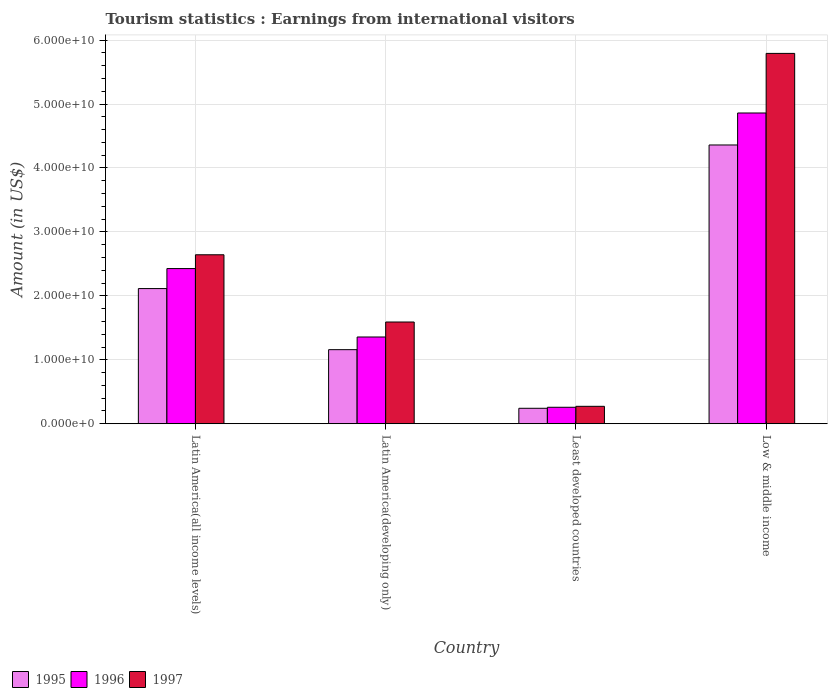How many groups of bars are there?
Your answer should be compact. 4. Are the number of bars per tick equal to the number of legend labels?
Give a very brief answer. Yes. Are the number of bars on each tick of the X-axis equal?
Your answer should be compact. Yes. How many bars are there on the 3rd tick from the left?
Offer a terse response. 3. What is the label of the 1st group of bars from the left?
Make the answer very short. Latin America(all income levels). What is the earnings from international visitors in 1997 in Latin America(developing only)?
Ensure brevity in your answer.  1.59e+1. Across all countries, what is the maximum earnings from international visitors in 1995?
Your response must be concise. 4.36e+1. Across all countries, what is the minimum earnings from international visitors in 1995?
Offer a very short reply. 2.42e+09. In which country was the earnings from international visitors in 1997 maximum?
Make the answer very short. Low & middle income. In which country was the earnings from international visitors in 1996 minimum?
Provide a succinct answer. Least developed countries. What is the total earnings from international visitors in 1997 in the graph?
Make the answer very short. 1.03e+11. What is the difference between the earnings from international visitors in 1995 in Latin America(all income levels) and that in Low & middle income?
Ensure brevity in your answer.  -2.25e+1. What is the difference between the earnings from international visitors in 1995 in Latin America(developing only) and the earnings from international visitors in 1997 in Least developed countries?
Your answer should be compact. 8.86e+09. What is the average earnings from international visitors in 1996 per country?
Keep it short and to the point. 2.23e+1. What is the difference between the earnings from international visitors of/in 1997 and earnings from international visitors of/in 1995 in Low & middle income?
Offer a very short reply. 1.43e+1. In how many countries, is the earnings from international visitors in 1997 greater than 10000000000 US$?
Your response must be concise. 3. What is the ratio of the earnings from international visitors in 1996 in Latin America(all income levels) to that in Latin America(developing only)?
Your answer should be very brief. 1.79. Is the earnings from international visitors in 1997 in Latin America(all income levels) less than that in Least developed countries?
Your response must be concise. No. Is the difference between the earnings from international visitors in 1997 in Latin America(developing only) and Least developed countries greater than the difference between the earnings from international visitors in 1995 in Latin America(developing only) and Least developed countries?
Ensure brevity in your answer.  Yes. What is the difference between the highest and the second highest earnings from international visitors in 1997?
Offer a terse response. -4.20e+1. What is the difference between the highest and the lowest earnings from international visitors in 1995?
Keep it short and to the point. 4.12e+1. In how many countries, is the earnings from international visitors in 1996 greater than the average earnings from international visitors in 1996 taken over all countries?
Keep it short and to the point. 2. Is the sum of the earnings from international visitors in 1997 in Latin America(developing only) and Least developed countries greater than the maximum earnings from international visitors in 1996 across all countries?
Give a very brief answer. No. What does the 1st bar from the right in Latin America(all income levels) represents?
Your answer should be very brief. 1997. How many bars are there?
Your answer should be compact. 12. Are all the bars in the graph horizontal?
Provide a short and direct response. No. Does the graph contain any zero values?
Provide a succinct answer. No. Does the graph contain grids?
Keep it short and to the point. Yes. How many legend labels are there?
Your response must be concise. 3. How are the legend labels stacked?
Your answer should be very brief. Horizontal. What is the title of the graph?
Provide a succinct answer. Tourism statistics : Earnings from international visitors. Does "1973" appear as one of the legend labels in the graph?
Your answer should be compact. No. What is the Amount (in US$) of 1995 in Latin America(all income levels)?
Make the answer very short. 2.11e+1. What is the Amount (in US$) in 1996 in Latin America(all income levels)?
Your answer should be compact. 2.43e+1. What is the Amount (in US$) of 1997 in Latin America(all income levels)?
Offer a terse response. 2.64e+1. What is the Amount (in US$) in 1995 in Latin America(developing only)?
Give a very brief answer. 1.16e+1. What is the Amount (in US$) in 1996 in Latin America(developing only)?
Provide a short and direct response. 1.36e+1. What is the Amount (in US$) of 1997 in Latin America(developing only)?
Provide a succinct answer. 1.59e+1. What is the Amount (in US$) of 1995 in Least developed countries?
Ensure brevity in your answer.  2.42e+09. What is the Amount (in US$) of 1996 in Least developed countries?
Provide a succinct answer. 2.57e+09. What is the Amount (in US$) in 1997 in Least developed countries?
Your answer should be compact. 2.72e+09. What is the Amount (in US$) in 1995 in Low & middle income?
Your answer should be very brief. 4.36e+1. What is the Amount (in US$) of 1996 in Low & middle income?
Your answer should be compact. 4.86e+1. What is the Amount (in US$) of 1997 in Low & middle income?
Make the answer very short. 5.79e+1. Across all countries, what is the maximum Amount (in US$) of 1995?
Give a very brief answer. 4.36e+1. Across all countries, what is the maximum Amount (in US$) in 1996?
Your answer should be very brief. 4.86e+1. Across all countries, what is the maximum Amount (in US$) of 1997?
Keep it short and to the point. 5.79e+1. Across all countries, what is the minimum Amount (in US$) of 1995?
Your answer should be compact. 2.42e+09. Across all countries, what is the minimum Amount (in US$) of 1996?
Make the answer very short. 2.57e+09. Across all countries, what is the minimum Amount (in US$) in 1997?
Your response must be concise. 2.72e+09. What is the total Amount (in US$) in 1995 in the graph?
Your response must be concise. 7.87e+1. What is the total Amount (in US$) of 1996 in the graph?
Provide a succinct answer. 8.90e+1. What is the total Amount (in US$) of 1997 in the graph?
Your answer should be very brief. 1.03e+11. What is the difference between the Amount (in US$) in 1995 in Latin America(all income levels) and that in Latin America(developing only)?
Make the answer very short. 9.55e+09. What is the difference between the Amount (in US$) in 1996 in Latin America(all income levels) and that in Latin America(developing only)?
Your answer should be very brief. 1.07e+1. What is the difference between the Amount (in US$) in 1997 in Latin America(all income levels) and that in Latin America(developing only)?
Your answer should be very brief. 1.05e+1. What is the difference between the Amount (in US$) in 1995 in Latin America(all income levels) and that in Least developed countries?
Provide a short and direct response. 1.87e+1. What is the difference between the Amount (in US$) of 1996 in Latin America(all income levels) and that in Least developed countries?
Your answer should be compact. 2.17e+1. What is the difference between the Amount (in US$) of 1997 in Latin America(all income levels) and that in Least developed countries?
Keep it short and to the point. 2.37e+1. What is the difference between the Amount (in US$) in 1995 in Latin America(all income levels) and that in Low & middle income?
Offer a very short reply. -2.25e+1. What is the difference between the Amount (in US$) of 1996 in Latin America(all income levels) and that in Low & middle income?
Provide a short and direct response. -2.43e+1. What is the difference between the Amount (in US$) in 1997 in Latin America(all income levels) and that in Low & middle income?
Offer a very short reply. -3.15e+1. What is the difference between the Amount (in US$) of 1995 in Latin America(developing only) and that in Least developed countries?
Provide a short and direct response. 9.17e+09. What is the difference between the Amount (in US$) of 1996 in Latin America(developing only) and that in Least developed countries?
Your response must be concise. 1.10e+1. What is the difference between the Amount (in US$) of 1997 in Latin America(developing only) and that in Least developed countries?
Make the answer very short. 1.32e+1. What is the difference between the Amount (in US$) in 1995 in Latin America(developing only) and that in Low & middle income?
Offer a terse response. -3.20e+1. What is the difference between the Amount (in US$) in 1996 in Latin America(developing only) and that in Low & middle income?
Give a very brief answer. -3.50e+1. What is the difference between the Amount (in US$) of 1997 in Latin America(developing only) and that in Low & middle income?
Make the answer very short. -4.20e+1. What is the difference between the Amount (in US$) in 1995 in Least developed countries and that in Low & middle income?
Offer a very short reply. -4.12e+1. What is the difference between the Amount (in US$) in 1996 in Least developed countries and that in Low & middle income?
Provide a succinct answer. -4.60e+1. What is the difference between the Amount (in US$) in 1997 in Least developed countries and that in Low & middle income?
Your answer should be very brief. -5.52e+1. What is the difference between the Amount (in US$) in 1995 in Latin America(all income levels) and the Amount (in US$) in 1996 in Latin America(developing only)?
Make the answer very short. 7.57e+09. What is the difference between the Amount (in US$) in 1995 in Latin America(all income levels) and the Amount (in US$) in 1997 in Latin America(developing only)?
Your answer should be very brief. 5.23e+09. What is the difference between the Amount (in US$) of 1996 in Latin America(all income levels) and the Amount (in US$) of 1997 in Latin America(developing only)?
Provide a succinct answer. 8.36e+09. What is the difference between the Amount (in US$) of 1995 in Latin America(all income levels) and the Amount (in US$) of 1996 in Least developed countries?
Give a very brief answer. 1.86e+1. What is the difference between the Amount (in US$) in 1995 in Latin America(all income levels) and the Amount (in US$) in 1997 in Least developed countries?
Make the answer very short. 1.84e+1. What is the difference between the Amount (in US$) in 1996 in Latin America(all income levels) and the Amount (in US$) in 1997 in Least developed countries?
Make the answer very short. 2.15e+1. What is the difference between the Amount (in US$) of 1995 in Latin America(all income levels) and the Amount (in US$) of 1996 in Low & middle income?
Ensure brevity in your answer.  -2.75e+1. What is the difference between the Amount (in US$) of 1995 in Latin America(all income levels) and the Amount (in US$) of 1997 in Low & middle income?
Your response must be concise. -3.68e+1. What is the difference between the Amount (in US$) in 1996 in Latin America(all income levels) and the Amount (in US$) in 1997 in Low & middle income?
Ensure brevity in your answer.  -3.37e+1. What is the difference between the Amount (in US$) in 1995 in Latin America(developing only) and the Amount (in US$) in 1996 in Least developed countries?
Give a very brief answer. 9.01e+09. What is the difference between the Amount (in US$) of 1995 in Latin America(developing only) and the Amount (in US$) of 1997 in Least developed countries?
Provide a succinct answer. 8.86e+09. What is the difference between the Amount (in US$) of 1996 in Latin America(developing only) and the Amount (in US$) of 1997 in Least developed countries?
Keep it short and to the point. 1.08e+1. What is the difference between the Amount (in US$) of 1995 in Latin America(developing only) and the Amount (in US$) of 1996 in Low & middle income?
Your response must be concise. -3.70e+1. What is the difference between the Amount (in US$) in 1995 in Latin America(developing only) and the Amount (in US$) in 1997 in Low & middle income?
Ensure brevity in your answer.  -4.63e+1. What is the difference between the Amount (in US$) of 1996 in Latin America(developing only) and the Amount (in US$) of 1997 in Low & middle income?
Keep it short and to the point. -4.44e+1. What is the difference between the Amount (in US$) in 1995 in Least developed countries and the Amount (in US$) in 1996 in Low & middle income?
Provide a succinct answer. -4.62e+1. What is the difference between the Amount (in US$) in 1995 in Least developed countries and the Amount (in US$) in 1997 in Low & middle income?
Offer a very short reply. -5.55e+1. What is the difference between the Amount (in US$) of 1996 in Least developed countries and the Amount (in US$) of 1997 in Low & middle income?
Your response must be concise. -5.53e+1. What is the average Amount (in US$) in 1995 per country?
Your response must be concise. 1.97e+1. What is the average Amount (in US$) of 1996 per country?
Make the answer very short. 2.23e+1. What is the average Amount (in US$) in 1997 per country?
Keep it short and to the point. 2.57e+1. What is the difference between the Amount (in US$) in 1995 and Amount (in US$) in 1996 in Latin America(all income levels)?
Give a very brief answer. -3.13e+09. What is the difference between the Amount (in US$) in 1995 and Amount (in US$) in 1997 in Latin America(all income levels)?
Your response must be concise. -5.29e+09. What is the difference between the Amount (in US$) of 1996 and Amount (in US$) of 1997 in Latin America(all income levels)?
Give a very brief answer. -2.16e+09. What is the difference between the Amount (in US$) in 1995 and Amount (in US$) in 1996 in Latin America(developing only)?
Offer a terse response. -1.98e+09. What is the difference between the Amount (in US$) in 1995 and Amount (in US$) in 1997 in Latin America(developing only)?
Give a very brief answer. -4.32e+09. What is the difference between the Amount (in US$) of 1996 and Amount (in US$) of 1997 in Latin America(developing only)?
Make the answer very short. -2.34e+09. What is the difference between the Amount (in US$) of 1995 and Amount (in US$) of 1996 in Least developed countries?
Your answer should be very brief. -1.58e+08. What is the difference between the Amount (in US$) of 1995 and Amount (in US$) of 1997 in Least developed countries?
Offer a very short reply. -3.09e+08. What is the difference between the Amount (in US$) of 1996 and Amount (in US$) of 1997 in Least developed countries?
Offer a very short reply. -1.51e+08. What is the difference between the Amount (in US$) in 1995 and Amount (in US$) in 1996 in Low & middle income?
Provide a short and direct response. -5.00e+09. What is the difference between the Amount (in US$) of 1995 and Amount (in US$) of 1997 in Low & middle income?
Your response must be concise. -1.43e+1. What is the difference between the Amount (in US$) in 1996 and Amount (in US$) in 1997 in Low & middle income?
Keep it short and to the point. -9.32e+09. What is the ratio of the Amount (in US$) of 1995 in Latin America(all income levels) to that in Latin America(developing only)?
Give a very brief answer. 1.82. What is the ratio of the Amount (in US$) in 1996 in Latin America(all income levels) to that in Latin America(developing only)?
Offer a very short reply. 1.79. What is the ratio of the Amount (in US$) in 1997 in Latin America(all income levels) to that in Latin America(developing only)?
Offer a terse response. 1.66. What is the ratio of the Amount (in US$) of 1995 in Latin America(all income levels) to that in Least developed countries?
Provide a succinct answer. 8.75. What is the ratio of the Amount (in US$) of 1996 in Latin America(all income levels) to that in Least developed countries?
Give a very brief answer. 9.43. What is the ratio of the Amount (in US$) in 1997 in Latin America(all income levels) to that in Least developed countries?
Your response must be concise. 9.7. What is the ratio of the Amount (in US$) in 1995 in Latin America(all income levels) to that in Low & middle income?
Ensure brevity in your answer.  0.48. What is the ratio of the Amount (in US$) in 1996 in Latin America(all income levels) to that in Low & middle income?
Your response must be concise. 0.5. What is the ratio of the Amount (in US$) in 1997 in Latin America(all income levels) to that in Low & middle income?
Offer a very short reply. 0.46. What is the ratio of the Amount (in US$) in 1995 in Latin America(developing only) to that in Least developed countries?
Offer a terse response. 4.79. What is the ratio of the Amount (in US$) in 1996 in Latin America(developing only) to that in Least developed countries?
Make the answer very short. 5.27. What is the ratio of the Amount (in US$) of 1997 in Latin America(developing only) to that in Least developed countries?
Provide a succinct answer. 5.84. What is the ratio of the Amount (in US$) of 1995 in Latin America(developing only) to that in Low & middle income?
Offer a very short reply. 0.27. What is the ratio of the Amount (in US$) of 1996 in Latin America(developing only) to that in Low & middle income?
Your answer should be compact. 0.28. What is the ratio of the Amount (in US$) of 1997 in Latin America(developing only) to that in Low & middle income?
Provide a succinct answer. 0.27. What is the ratio of the Amount (in US$) in 1995 in Least developed countries to that in Low & middle income?
Keep it short and to the point. 0.06. What is the ratio of the Amount (in US$) of 1996 in Least developed countries to that in Low & middle income?
Offer a terse response. 0.05. What is the ratio of the Amount (in US$) in 1997 in Least developed countries to that in Low & middle income?
Offer a very short reply. 0.05. What is the difference between the highest and the second highest Amount (in US$) of 1995?
Your answer should be compact. 2.25e+1. What is the difference between the highest and the second highest Amount (in US$) in 1996?
Offer a very short reply. 2.43e+1. What is the difference between the highest and the second highest Amount (in US$) of 1997?
Your answer should be compact. 3.15e+1. What is the difference between the highest and the lowest Amount (in US$) in 1995?
Make the answer very short. 4.12e+1. What is the difference between the highest and the lowest Amount (in US$) of 1996?
Your answer should be compact. 4.60e+1. What is the difference between the highest and the lowest Amount (in US$) in 1997?
Your answer should be compact. 5.52e+1. 